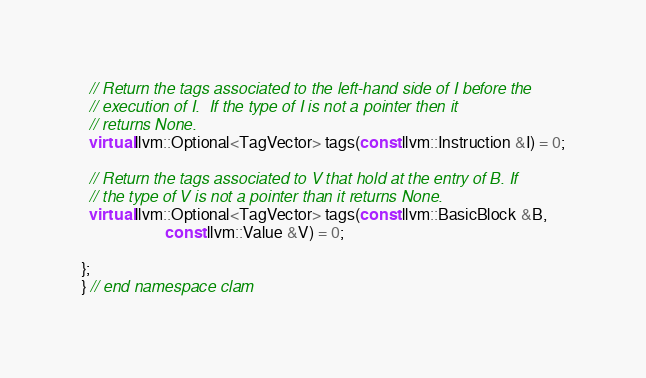Convert code to text. <code><loc_0><loc_0><loc_500><loc_500><_C++_>
  // Return the tags associated to the left-hand side of I before the
  // execution of I.  If the type of I is not a pointer then it
  // returns None.
  virtual llvm::Optional<TagVector> tags(const llvm::Instruction &I) = 0;

  // Return the tags associated to V that hold at the entry of B. If
  // the type of V is not a pointer than it returns None.
  virtual llvm::Optional<TagVector> tags(const llvm::BasicBlock &B,
					 const llvm::Value &V) = 0;
  
};
} // end namespace clam
</code> 